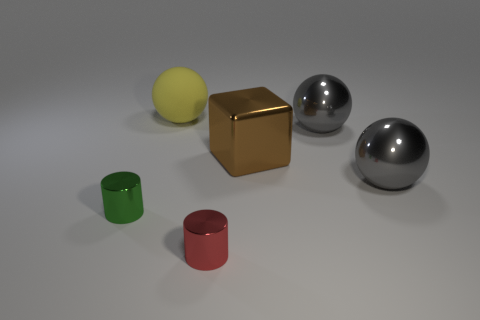Add 1 big gray balls. How many objects exist? 7 Subtract all cylinders. How many objects are left? 4 Subtract all gray spheres. Subtract all yellow balls. How many objects are left? 3 Add 6 red cylinders. How many red cylinders are left? 7 Add 5 big gray metal objects. How many big gray metal objects exist? 7 Subtract 0 yellow blocks. How many objects are left? 6 